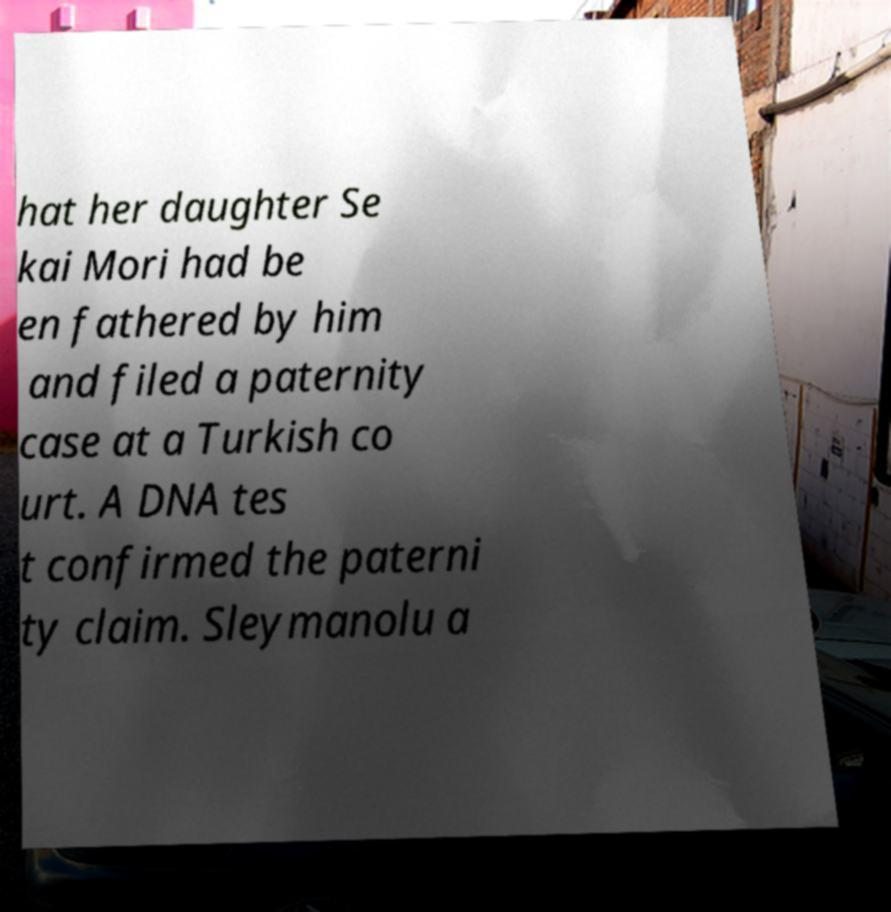There's text embedded in this image that I need extracted. Can you transcribe it verbatim? hat her daughter Se kai Mori had be en fathered by him and filed a paternity case at a Turkish co urt. A DNA tes t confirmed the paterni ty claim. Sleymanolu a 